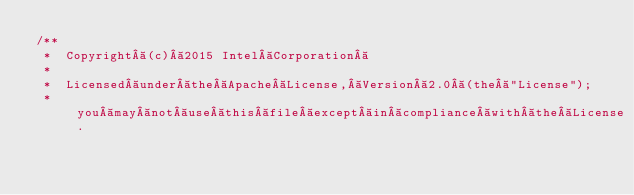Convert code to text. <code><loc_0><loc_0><loc_500><loc_500><_Scala_>/**
 *  Copyright (c) 2015 Intel Corporation 
 *
 *  Licensed under the Apache License, Version 2.0 (the "License");
 *  you may not use this file except in compliance with the License.</code> 